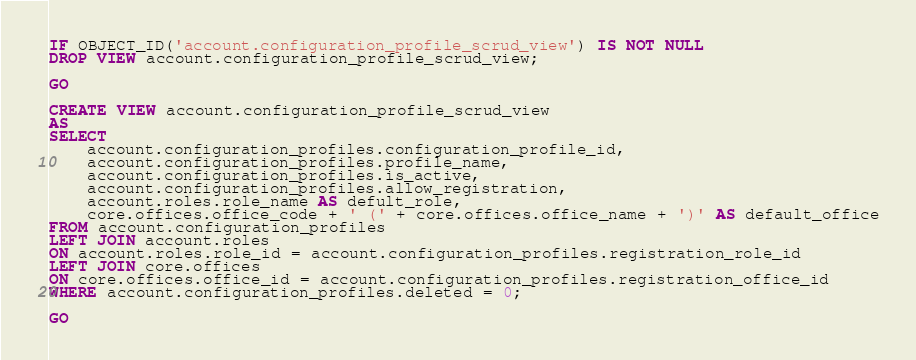Convert code to text. <code><loc_0><loc_0><loc_500><loc_500><_SQL_>IF OBJECT_ID('account.configuration_profile_scrud_view') IS NOT NULL
DROP VIEW account.configuration_profile_scrud_view;

GO

CREATE VIEW account.configuration_profile_scrud_view
AS
SELECT
	account.configuration_profiles.configuration_profile_id,
	account.configuration_profiles.profile_name,
	account.configuration_profiles.is_active,
	account.configuration_profiles.allow_registration,
	account.roles.role_name AS defult_role,
	core.offices.office_code + ' (' + core.offices.office_name + ')' AS default_office
FROM account.configuration_profiles
LEFT JOIN account.roles
ON account.roles.role_id = account.configuration_profiles.registration_role_id
LEFT JOIN core.offices
ON core.offices.office_id = account.configuration_profiles.registration_office_id
WHERE account.configuration_profiles.deleted = 0;

GO</code> 